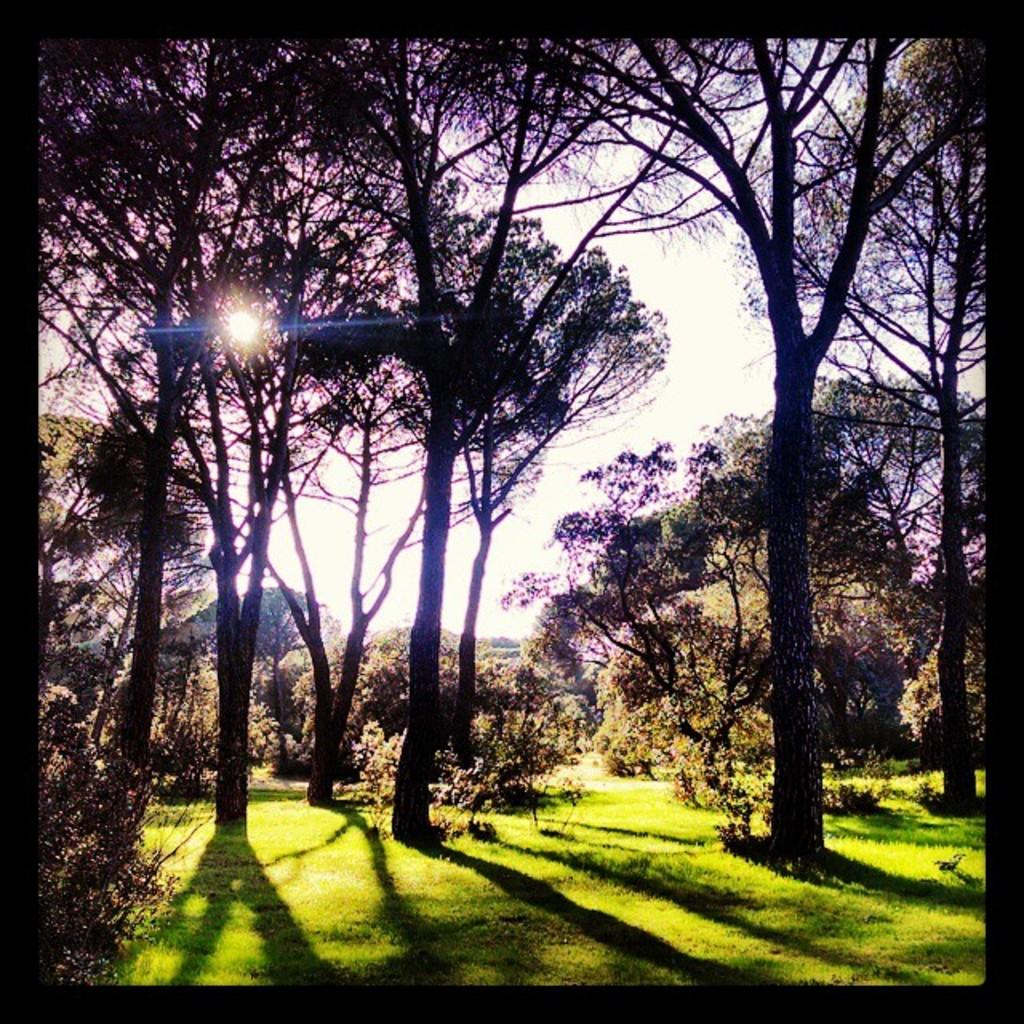What type of vegetation can be seen in the image? There are trees in the image. What is present at the bottom of the image? There is grass at the bottom of the image. What part of the natural environment is visible in the background of the image? The sky is visible in the background of the image. How many teeth can be seen in the image? There are no teeth present in the image. Is the image completely silent, or can any sounds be heard? The image is silent, as it is a visual representation and does not include any sounds. 